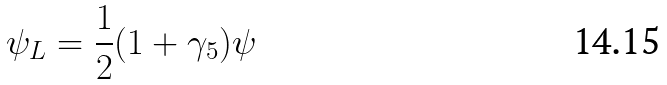<formula> <loc_0><loc_0><loc_500><loc_500>\psi _ { L } = \frac { 1 } { 2 } ( 1 + \gamma _ { 5 } ) \psi</formula> 